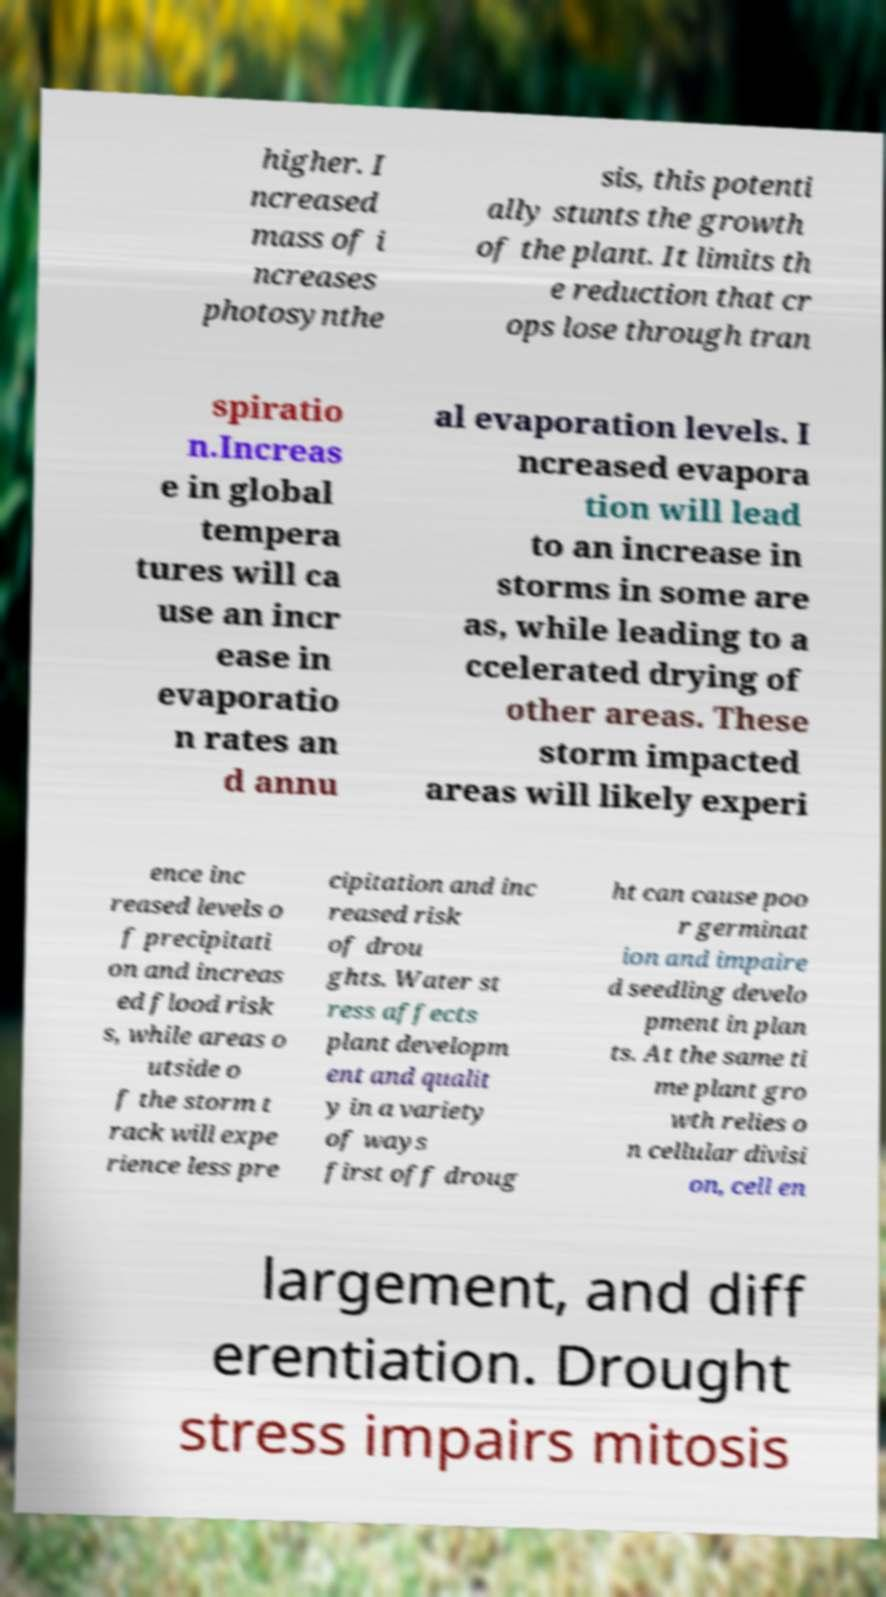For documentation purposes, I need the text within this image transcribed. Could you provide that? higher. I ncreased mass of i ncreases photosynthe sis, this potenti ally stunts the growth of the plant. It limits th e reduction that cr ops lose through tran spiratio n.Increas e in global tempera tures will ca use an incr ease in evaporatio n rates an d annu al evaporation levels. I ncreased evapora tion will lead to an increase in storms in some are as, while leading to a ccelerated drying of other areas. These storm impacted areas will likely experi ence inc reased levels o f precipitati on and increas ed flood risk s, while areas o utside o f the storm t rack will expe rience less pre cipitation and inc reased risk of drou ghts. Water st ress affects plant developm ent and qualit y in a variety of ways first off droug ht can cause poo r germinat ion and impaire d seedling develo pment in plan ts. At the same ti me plant gro wth relies o n cellular divisi on, cell en largement, and diff erentiation. Drought stress impairs mitosis 